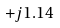<formula> <loc_0><loc_0><loc_500><loc_500>+ j 1 . 1 4</formula> 